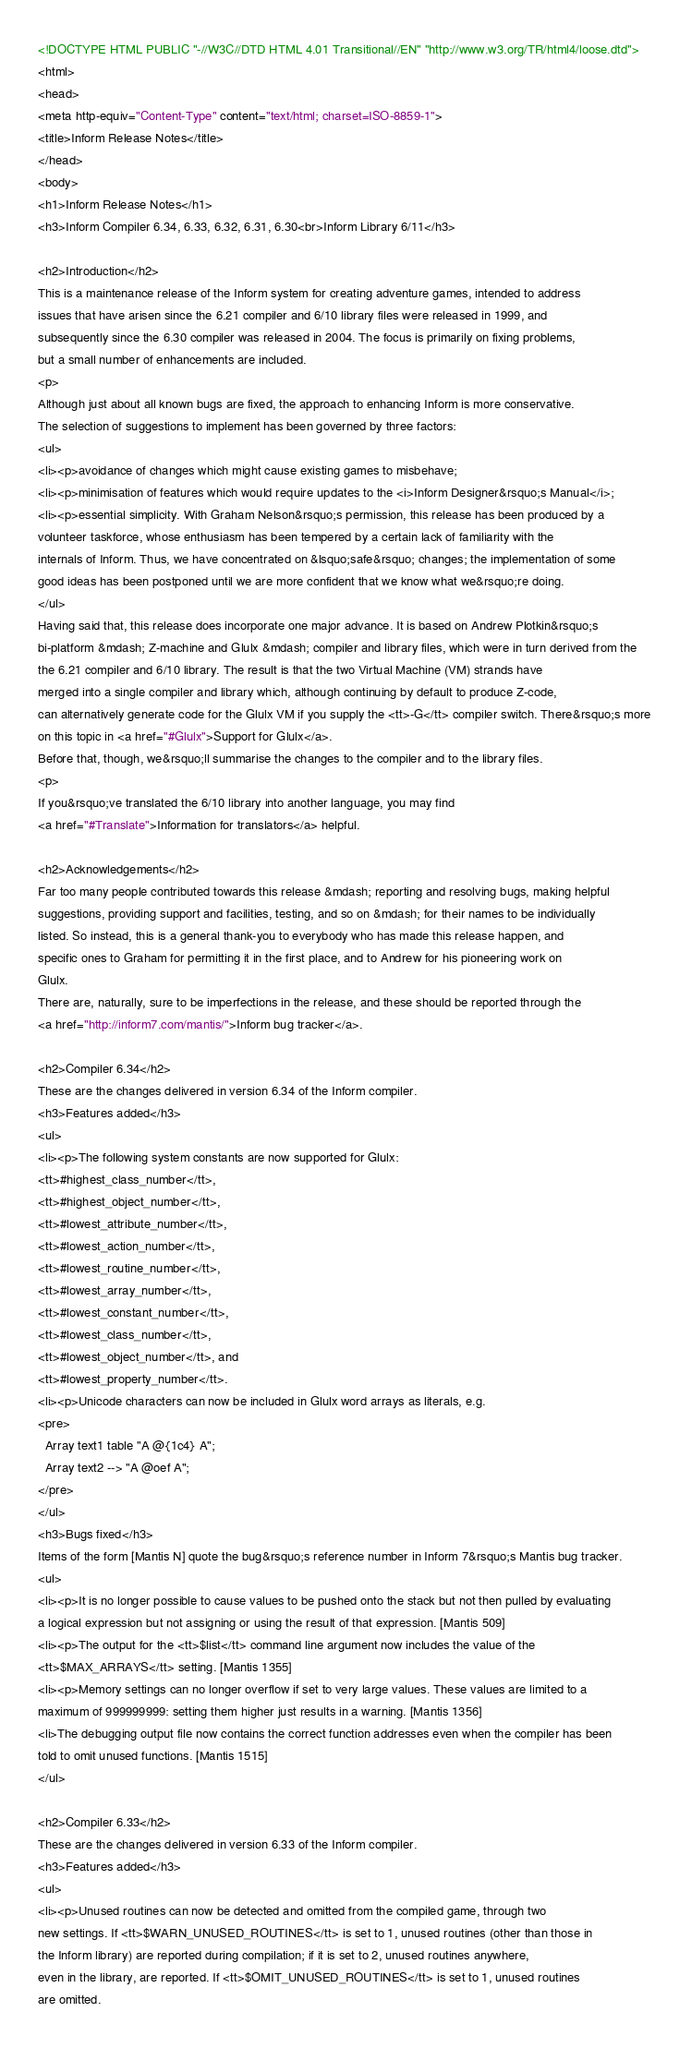Convert code to text. <code><loc_0><loc_0><loc_500><loc_500><_HTML_><!DOCTYPE HTML PUBLIC "-//W3C//DTD HTML 4.01 Transitional//EN" "http://www.w3.org/TR/html4/loose.dtd">
<html>
<head>
<meta http-equiv="Content-Type" content="text/html; charset=ISO-8859-1">
<title>Inform Release Notes</title>
</head>
<body>
<h1>Inform Release Notes</h1>
<h3>Inform Compiler 6.34, 6.33, 6.32, 6.31, 6.30<br>Inform Library 6/11</h3>

<h2>Introduction</h2>
This is a maintenance release of the Inform system for creating adventure games, intended to address 
issues that have arisen since the 6.21 compiler and 6/10 library files were released in 1999, and 
subsequently since the 6.30 compiler was released in 2004. The focus is primarily on fixing problems,
but a small number of enhancements are included.
<p>
Although just about all known bugs are fixed, the approach to enhancing Inform is more conservative. 
The selection of suggestions to implement has been governed by three factors:
<ul>
<li><p>avoidance of changes which might cause existing games to misbehave;
<li><p>minimisation of features which would require updates to the <i>Inform Designer&rsquo;s Manual</i>;
<li><p>essential simplicity. With Graham Nelson&rsquo;s permission, this release has been produced by a 
volunteer taskforce, whose enthusiasm has been tempered by a certain lack of familiarity with the 
internals of Inform. Thus, we have concentrated on &lsquo;safe&rsquo; changes; the implementation of some 
good ideas has been postponed until we are more confident that we know what we&rsquo;re doing.
</ul>
Having said that, this release does incorporate one major advance. It is based on Andrew Plotkin&rsquo;s 
bi-platform &mdash; Z-machine and Glulx &mdash; compiler and library files, which were in turn derived from the 
the 6.21 compiler and 6/10 library. The result is that the two Virtual Machine (VM) strands have 
merged into a single compiler and library which, although continuing by default to produce Z-code, 
can alternatively generate code for the Glulx VM if you supply the <tt>-G</tt> compiler switch. There&rsquo;s more 
on this topic in <a href="#Glulx">Support for Glulx</a>.
Before that, though, we&rsquo;ll summarise the changes to the compiler and to the library files.
<p>
If you&rsquo;ve translated the 6/10 library into another language, you may find
<a href="#Translate">Information for translators</a> helpful.

<h2>Acknowledgements</h2>
Far too many people contributed towards this release &mdash; reporting and resolving bugs, making helpful 
suggestions, providing support and facilities, testing, and so on &mdash; for their names to be individually 
listed. So instead, this is a general thank-you to everybody who has made this release happen, and 
specific ones to Graham for permitting it in the first place, and to Andrew for his pioneering work on 
Glulx.
There are, naturally, sure to be imperfections in the release, and these should be reported through the
<a href="http://inform7.com/mantis/">Inform bug tracker</a>.

<h2>Compiler 6.34</h2>
These are the changes delivered in version 6.34 of the Inform compiler.
<h3>Features added</h3>
<ul>
<li><p>The following system constants are now supported for Glulx:
<tt>#highest_class_number</tt>,
<tt>#highest_object_number</tt>,
<tt>#lowest_attribute_number</tt>,
<tt>#lowest_action_number</tt>,
<tt>#lowest_routine_number</tt>,
<tt>#lowest_array_number</tt>,
<tt>#lowest_constant_number</tt>,
<tt>#lowest_class_number</tt>,
<tt>#lowest_object_number</tt>, and
<tt>#lowest_property_number</tt>.
<li><p>Unicode characters can now be included in Glulx word arrays as literals, e.g.
<pre>
  Array text1 table "A @{1c4} A";
  Array text2 --> "A @oef A";
</pre>
</ul>
<h3>Bugs fixed</h3>
Items of the form [Mantis N] quote the bug&rsquo;s reference number in Inform 7&rsquo;s Mantis bug tracker. 
<ul>
<li><p>It is no longer possible to cause values to be pushed onto the stack but not then pulled by evaluating
a logical expression but not assigning or using the result of that expression. [Mantis 509]
<li><p>The output for the <tt>$list</tt> command line argument now includes the value of the
<tt>$MAX_ARRAYS</tt> setting. [Mantis 1355]
<li><p>Memory settings can no longer overflow if set to very large values. These values are limited to a
maximum of 999999999: setting them higher just results in a warning. [Mantis 1356]
<li>The debugging output file now contains the correct function addresses even when the compiler has been
told to omit unused functions. [Mantis 1515]
</ul>

<h2>Compiler 6.33</h2>
These are the changes delivered in version 6.33 of the Inform compiler.
<h3>Features added</h3>
<ul>
<li><p>Unused routines can now be detected and omitted from the compiled game, through two
new settings. If <tt>$WARN_UNUSED_ROUTINES</tt> is set to 1, unused routines (other than those in
the Inform library) are reported during compilation; if it is set to 2, unused routines anywhere,
even in the library, are reported. If <tt>$OMIT_UNUSED_ROUTINES</tt> is set to 1, unused routines
are omitted.</code> 